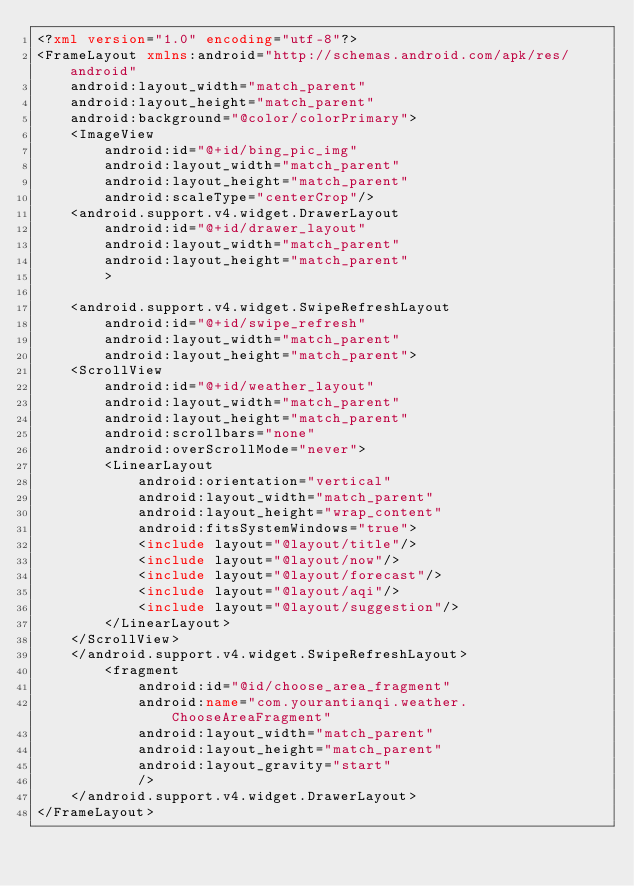<code> <loc_0><loc_0><loc_500><loc_500><_XML_><?xml version="1.0" encoding="utf-8"?>
<FrameLayout xmlns:android="http://schemas.android.com/apk/res/android"
    android:layout_width="match_parent"
    android:layout_height="match_parent"
    android:background="@color/colorPrimary">
    <ImageView
        android:id="@+id/bing_pic_img"
        android:layout_width="match_parent"
        android:layout_height="match_parent"
        android:scaleType="centerCrop"/>
    <android.support.v4.widget.DrawerLayout
        android:id="@+id/drawer_layout"
        android:layout_width="match_parent"
        android:layout_height="match_parent"
        >

    <android.support.v4.widget.SwipeRefreshLayout
        android:id="@+id/swipe_refresh"
        android:layout_width="match_parent"
        android:layout_height="match_parent">
    <ScrollView
        android:id="@+id/weather_layout"
        android:layout_width="match_parent"
        android:layout_height="match_parent"
        android:scrollbars="none"
        android:overScrollMode="never">
        <LinearLayout
            android:orientation="vertical"
            android:layout_width="match_parent"
            android:layout_height="wrap_content"
            android:fitsSystemWindows="true">
            <include layout="@layout/title"/>
            <include layout="@layout/now"/>
            <include layout="@layout/forecast"/>
            <include layout="@layout/aqi"/>
            <include layout="@layout/suggestion"/>
        </LinearLayout>
    </ScrollView>
    </android.support.v4.widget.SwipeRefreshLayout>
        <fragment
            android:id="@id/choose_area_fragment"
            android:name="com.yourantianqi.weather.ChooseAreaFragment"
            android:layout_width="match_parent"
            android:layout_height="match_parent"
            android:layout_gravity="start"
            />
    </android.support.v4.widget.DrawerLayout>
</FrameLayout>
</code> 